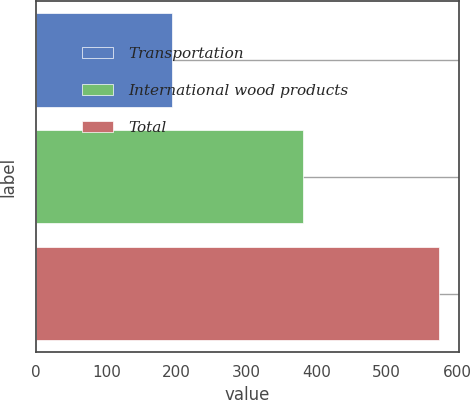<chart> <loc_0><loc_0><loc_500><loc_500><bar_chart><fcel>Transportation<fcel>International wood products<fcel>Total<nl><fcel>194<fcel>380<fcel>574<nl></chart> 